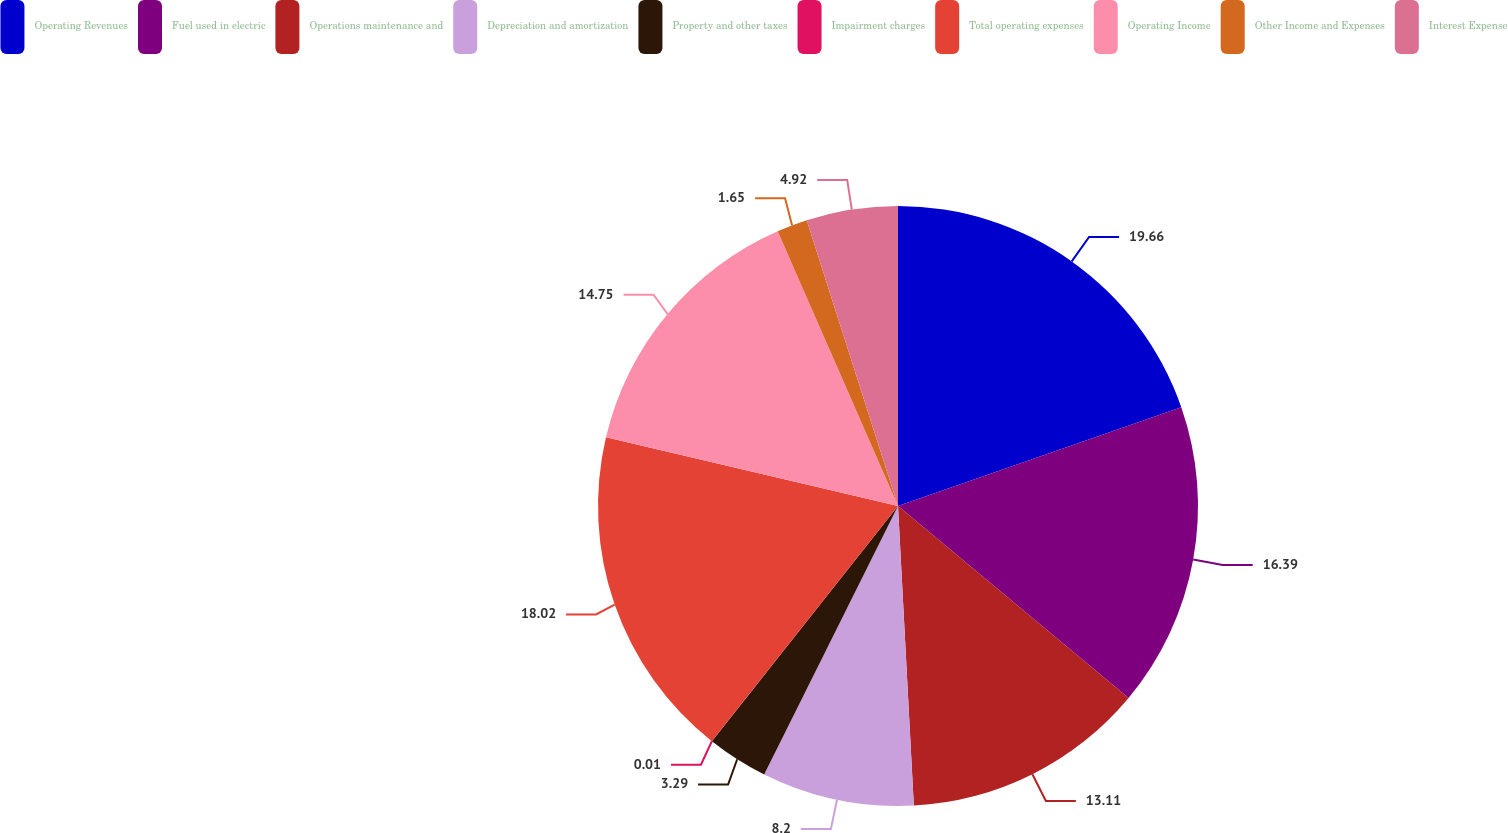<chart> <loc_0><loc_0><loc_500><loc_500><pie_chart><fcel>Operating Revenues<fcel>Fuel used in electric<fcel>Operations maintenance and<fcel>Depreciation and amortization<fcel>Property and other taxes<fcel>Impairment charges<fcel>Total operating expenses<fcel>Operating Income<fcel>Other Income and Expenses<fcel>Interest Expense<nl><fcel>19.66%<fcel>16.39%<fcel>13.11%<fcel>8.2%<fcel>3.29%<fcel>0.01%<fcel>18.02%<fcel>14.75%<fcel>1.65%<fcel>4.92%<nl></chart> 